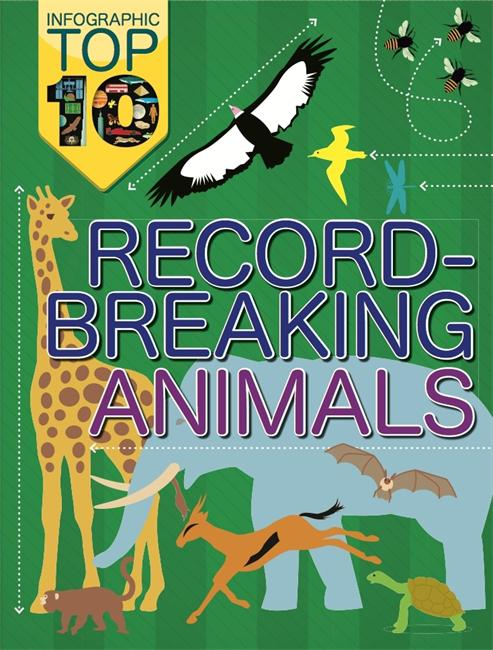Can you tell more about the flying bird in the infographic and the record it might hold? The bird illustrated, with its impressive wingspan, could be the wandering albatross, known for having the longest wingspan of any living bird, typically ranging from 8 to 11 feet. This adaptation enables it to soar vast distances over the oceans with minimal energy expenditure, a record-breaking feat of endurance and distance flying in the animal kingdom. 